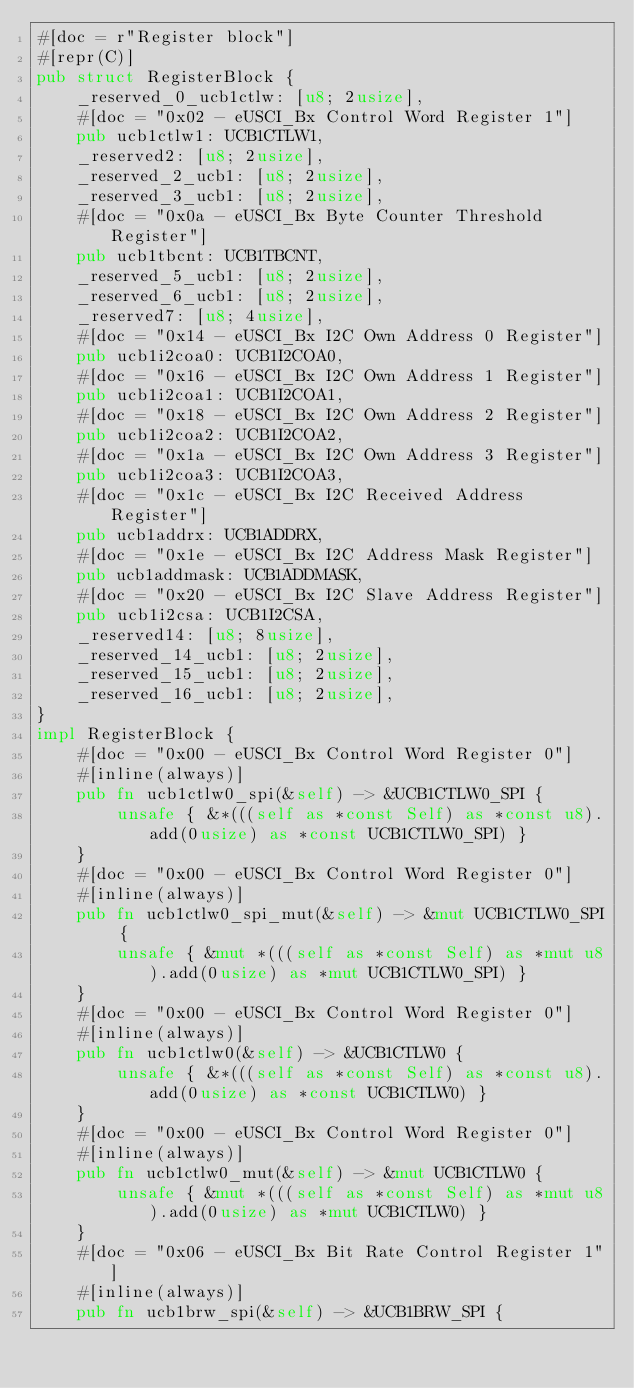<code> <loc_0><loc_0><loc_500><loc_500><_Rust_>#[doc = r"Register block"]
#[repr(C)]
pub struct RegisterBlock {
    _reserved_0_ucb1ctlw: [u8; 2usize],
    #[doc = "0x02 - eUSCI_Bx Control Word Register 1"]
    pub ucb1ctlw1: UCB1CTLW1,
    _reserved2: [u8; 2usize],
    _reserved_2_ucb1: [u8; 2usize],
    _reserved_3_ucb1: [u8; 2usize],
    #[doc = "0x0a - eUSCI_Bx Byte Counter Threshold Register"]
    pub ucb1tbcnt: UCB1TBCNT,
    _reserved_5_ucb1: [u8; 2usize],
    _reserved_6_ucb1: [u8; 2usize],
    _reserved7: [u8; 4usize],
    #[doc = "0x14 - eUSCI_Bx I2C Own Address 0 Register"]
    pub ucb1i2coa0: UCB1I2COA0,
    #[doc = "0x16 - eUSCI_Bx I2C Own Address 1 Register"]
    pub ucb1i2coa1: UCB1I2COA1,
    #[doc = "0x18 - eUSCI_Bx I2C Own Address 2 Register"]
    pub ucb1i2coa2: UCB1I2COA2,
    #[doc = "0x1a - eUSCI_Bx I2C Own Address 3 Register"]
    pub ucb1i2coa3: UCB1I2COA3,
    #[doc = "0x1c - eUSCI_Bx I2C Received Address Register"]
    pub ucb1addrx: UCB1ADDRX,
    #[doc = "0x1e - eUSCI_Bx I2C Address Mask Register"]
    pub ucb1addmask: UCB1ADDMASK,
    #[doc = "0x20 - eUSCI_Bx I2C Slave Address Register"]
    pub ucb1i2csa: UCB1I2CSA,
    _reserved14: [u8; 8usize],
    _reserved_14_ucb1: [u8; 2usize],
    _reserved_15_ucb1: [u8; 2usize],
    _reserved_16_ucb1: [u8; 2usize],
}
impl RegisterBlock {
    #[doc = "0x00 - eUSCI_Bx Control Word Register 0"]
    #[inline(always)]
    pub fn ucb1ctlw0_spi(&self) -> &UCB1CTLW0_SPI {
        unsafe { &*(((self as *const Self) as *const u8).add(0usize) as *const UCB1CTLW0_SPI) }
    }
    #[doc = "0x00 - eUSCI_Bx Control Word Register 0"]
    #[inline(always)]
    pub fn ucb1ctlw0_spi_mut(&self) -> &mut UCB1CTLW0_SPI {
        unsafe { &mut *(((self as *const Self) as *mut u8).add(0usize) as *mut UCB1CTLW0_SPI) }
    }
    #[doc = "0x00 - eUSCI_Bx Control Word Register 0"]
    #[inline(always)]
    pub fn ucb1ctlw0(&self) -> &UCB1CTLW0 {
        unsafe { &*(((self as *const Self) as *const u8).add(0usize) as *const UCB1CTLW0) }
    }
    #[doc = "0x00 - eUSCI_Bx Control Word Register 0"]
    #[inline(always)]
    pub fn ucb1ctlw0_mut(&self) -> &mut UCB1CTLW0 {
        unsafe { &mut *(((self as *const Self) as *mut u8).add(0usize) as *mut UCB1CTLW0) }
    }
    #[doc = "0x06 - eUSCI_Bx Bit Rate Control Register 1"]
    #[inline(always)]
    pub fn ucb1brw_spi(&self) -> &UCB1BRW_SPI {</code> 